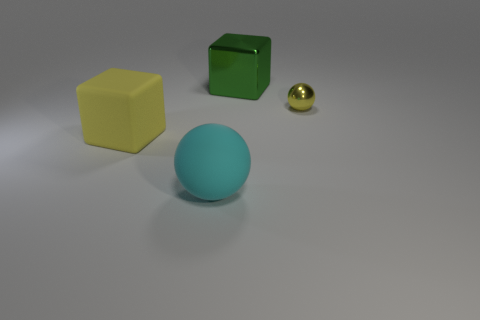How many objects are either things behind the tiny yellow shiny ball or large green blocks that are right of the big yellow object?
Provide a short and direct response. 1. Is the rubber cube the same size as the rubber ball?
Offer a terse response. Yes. What number of balls are yellow rubber things or big metallic things?
Offer a very short reply. 0. What number of things are left of the small yellow sphere and right of the rubber ball?
Your answer should be compact. 1. Do the matte cube and the cube right of the large cyan matte thing have the same size?
Your answer should be compact. Yes. Is there a rubber ball that is behind the metallic object in front of the thing that is behind the metal sphere?
Ensure brevity in your answer.  No. There is a thing that is in front of the large block to the left of the cyan object; what is it made of?
Your answer should be compact. Rubber. There is a big object that is both to the right of the yellow cube and left of the large green object; what is its material?
Give a very brief answer. Rubber. Is there another purple metallic thing of the same shape as the big metal thing?
Ensure brevity in your answer.  No. Are there any things that are on the right side of the shiny object in front of the green metal thing?
Offer a very short reply. No. 